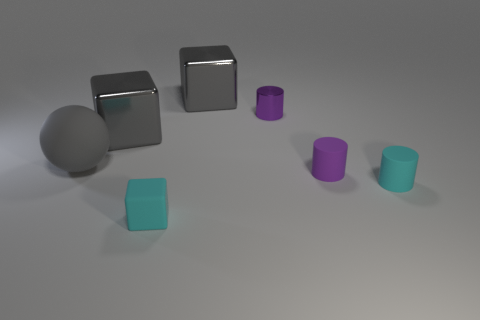There is a purple metal object that is the same size as the purple matte cylinder; what shape is it?
Your response must be concise. Cylinder. What number of objects are either tiny cylinders that are in front of the purple metallic object or small cylinders that are in front of the big gray sphere?
Keep it short and to the point. 2. What material is the cyan thing that is the same size as the cyan cylinder?
Provide a succinct answer. Rubber. Are there an equal number of large matte things to the right of the tiny purple metal object and cylinders right of the purple rubber cylinder?
Your answer should be compact. No. What number of purple objects are either big shiny balls or tiny matte cylinders?
Provide a short and direct response. 1. There is a tiny block; does it have the same color as the metallic cube that is behind the purple metallic thing?
Your answer should be very brief. No. What number of other objects are there of the same color as the small matte cube?
Offer a very short reply. 1. Are there fewer big cubes than large red matte spheres?
Your answer should be compact. No. There is a tiny matte thing that is on the left side of the purple thing that is in front of the large gray ball; how many large shiny things are right of it?
Make the answer very short. 1. What is the size of the purple cylinder that is in front of the gray sphere?
Offer a terse response. Small. 